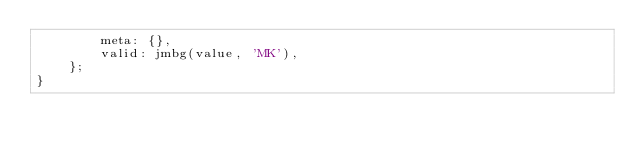Convert code to text. <code><loc_0><loc_0><loc_500><loc_500><_TypeScript_>        meta: {},
        valid: jmbg(value, 'MK'),
    };
}
</code> 